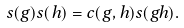<formula> <loc_0><loc_0><loc_500><loc_500>s ( g ) s ( h ) = c ( g , h ) s ( g h ) .</formula> 